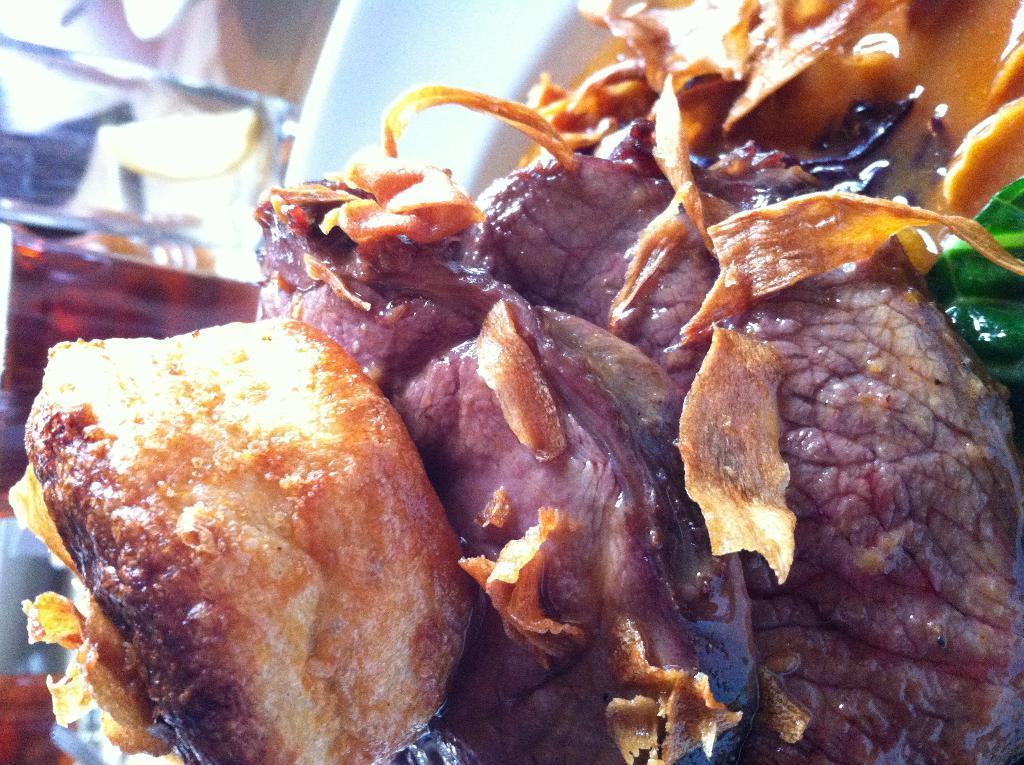Can you describe this image briefly? In this image we can see a plate containing meat and some food. 